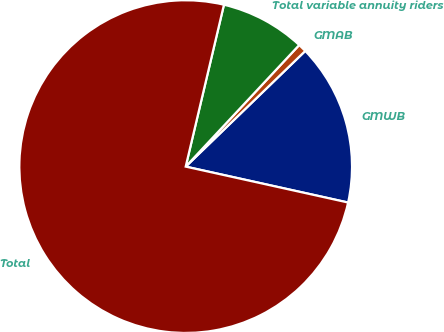<chart> <loc_0><loc_0><loc_500><loc_500><pie_chart><fcel>GMWB<fcel>GMAB<fcel>Total variable annuity riders<fcel>Total<nl><fcel>15.7%<fcel>0.81%<fcel>8.26%<fcel>75.23%<nl></chart> 